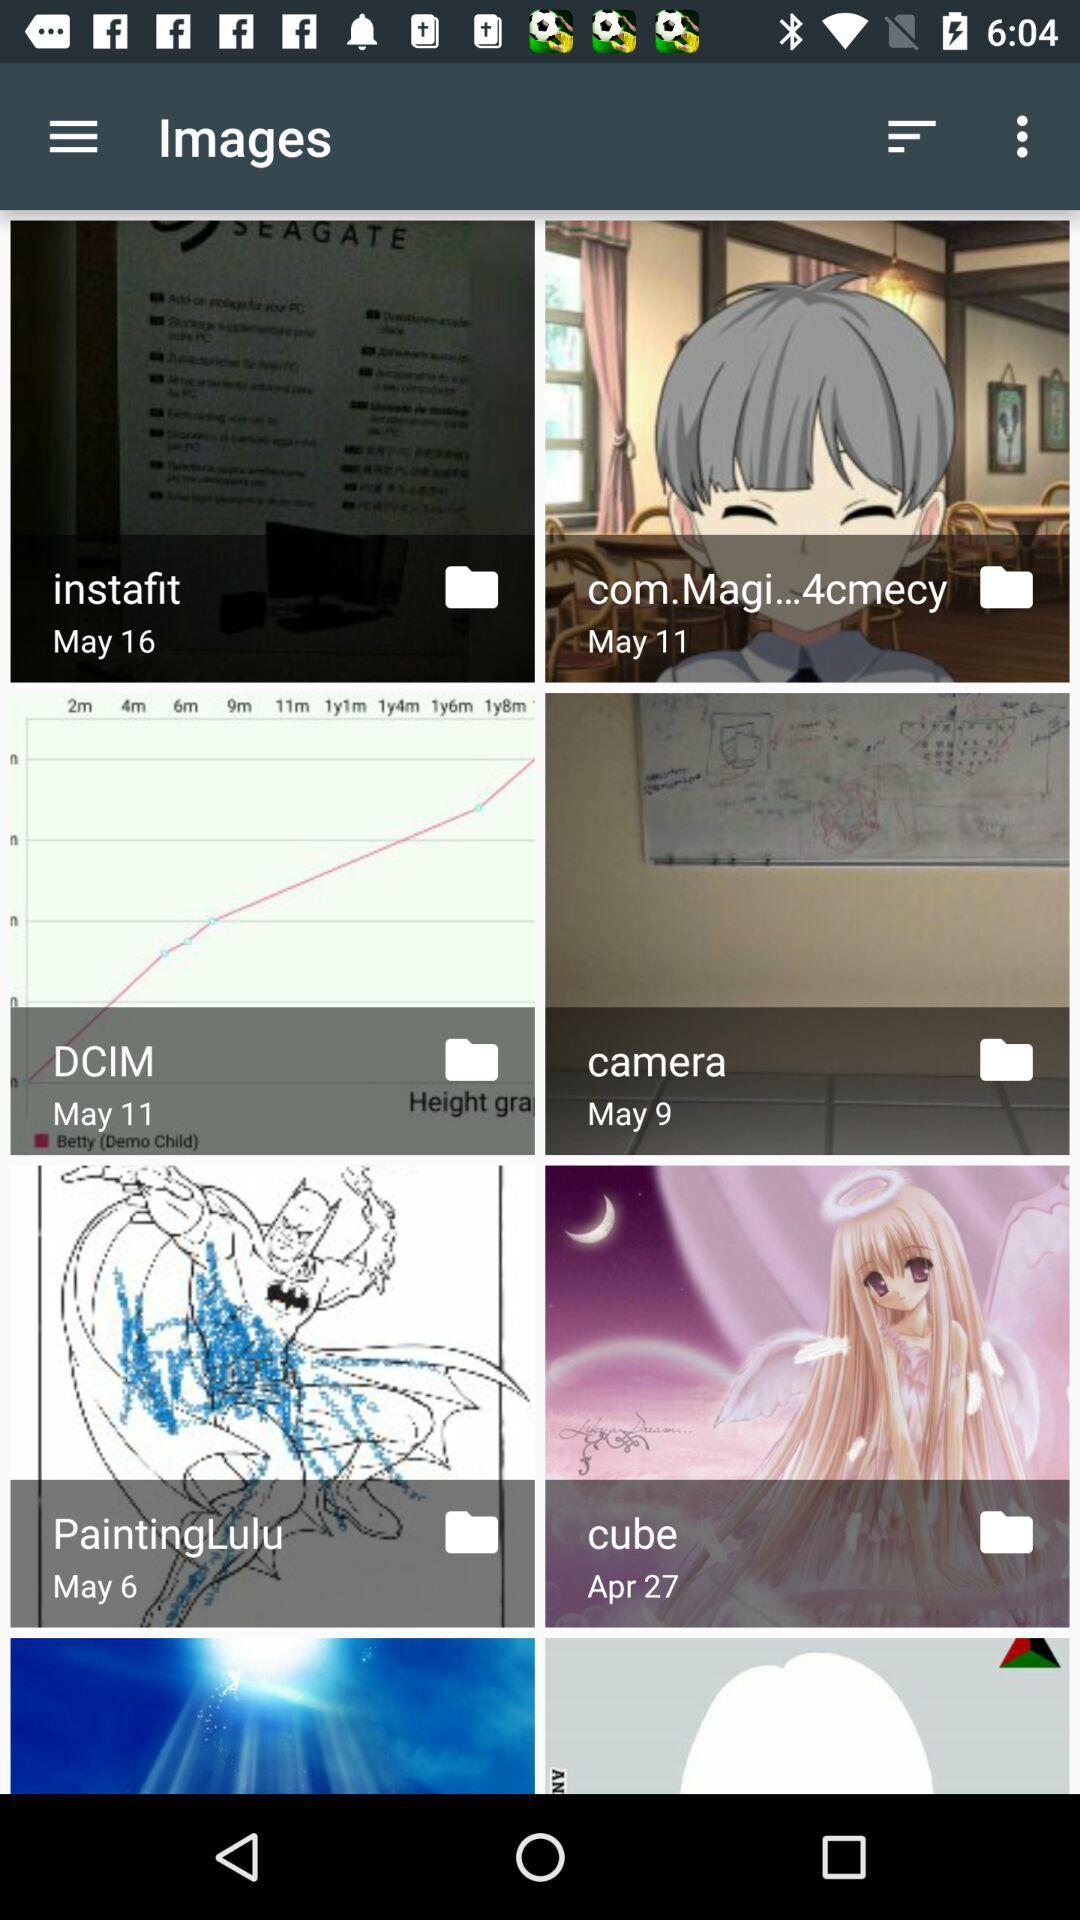On which date was the "DCIM" folder created? The folder was created on May 11. 